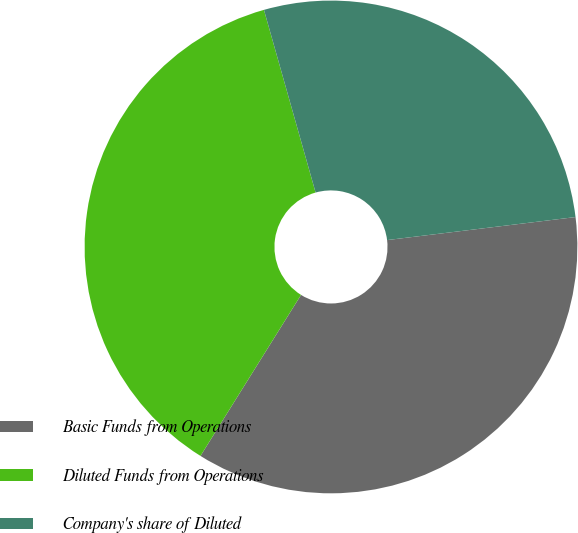<chart> <loc_0><loc_0><loc_500><loc_500><pie_chart><fcel>Basic Funds from Operations<fcel>Diluted Funds from Operations<fcel>Company's share of Diluted<nl><fcel>35.82%<fcel>36.73%<fcel>27.45%<nl></chart> 